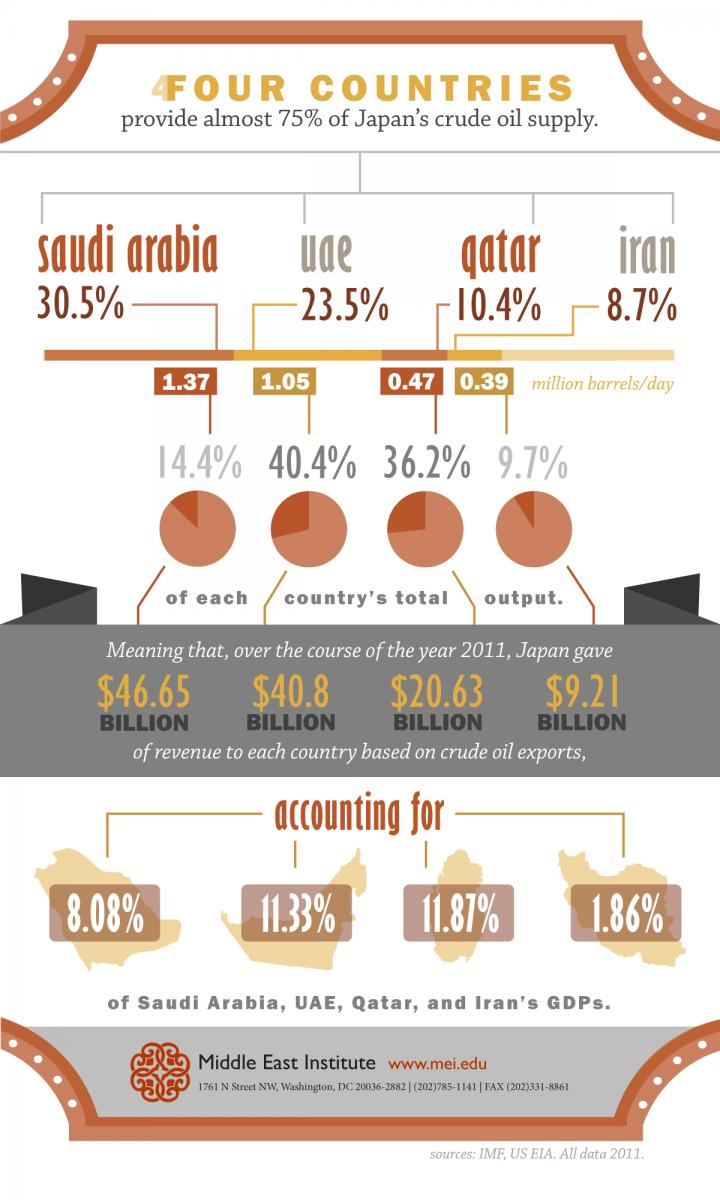Identify some key points in this picture. In 2011, Qatar supplied 10.4% of Japan's crude oil supply. In 2011, Qatar received a total of $20.63 billion in revenue from Japan based on crude oil exports. In 2011, Japan purchased crude oil from Iran worth $9.21 billion. In 2011, crude oil exports from Saudi Arabia to Japan accounted for 8.08% of the country's Gross Domestic Product. In 2011, crude oil exports to Japan accounted for 11.87% of Qatar's total Gross Domestic Product (GDP). 